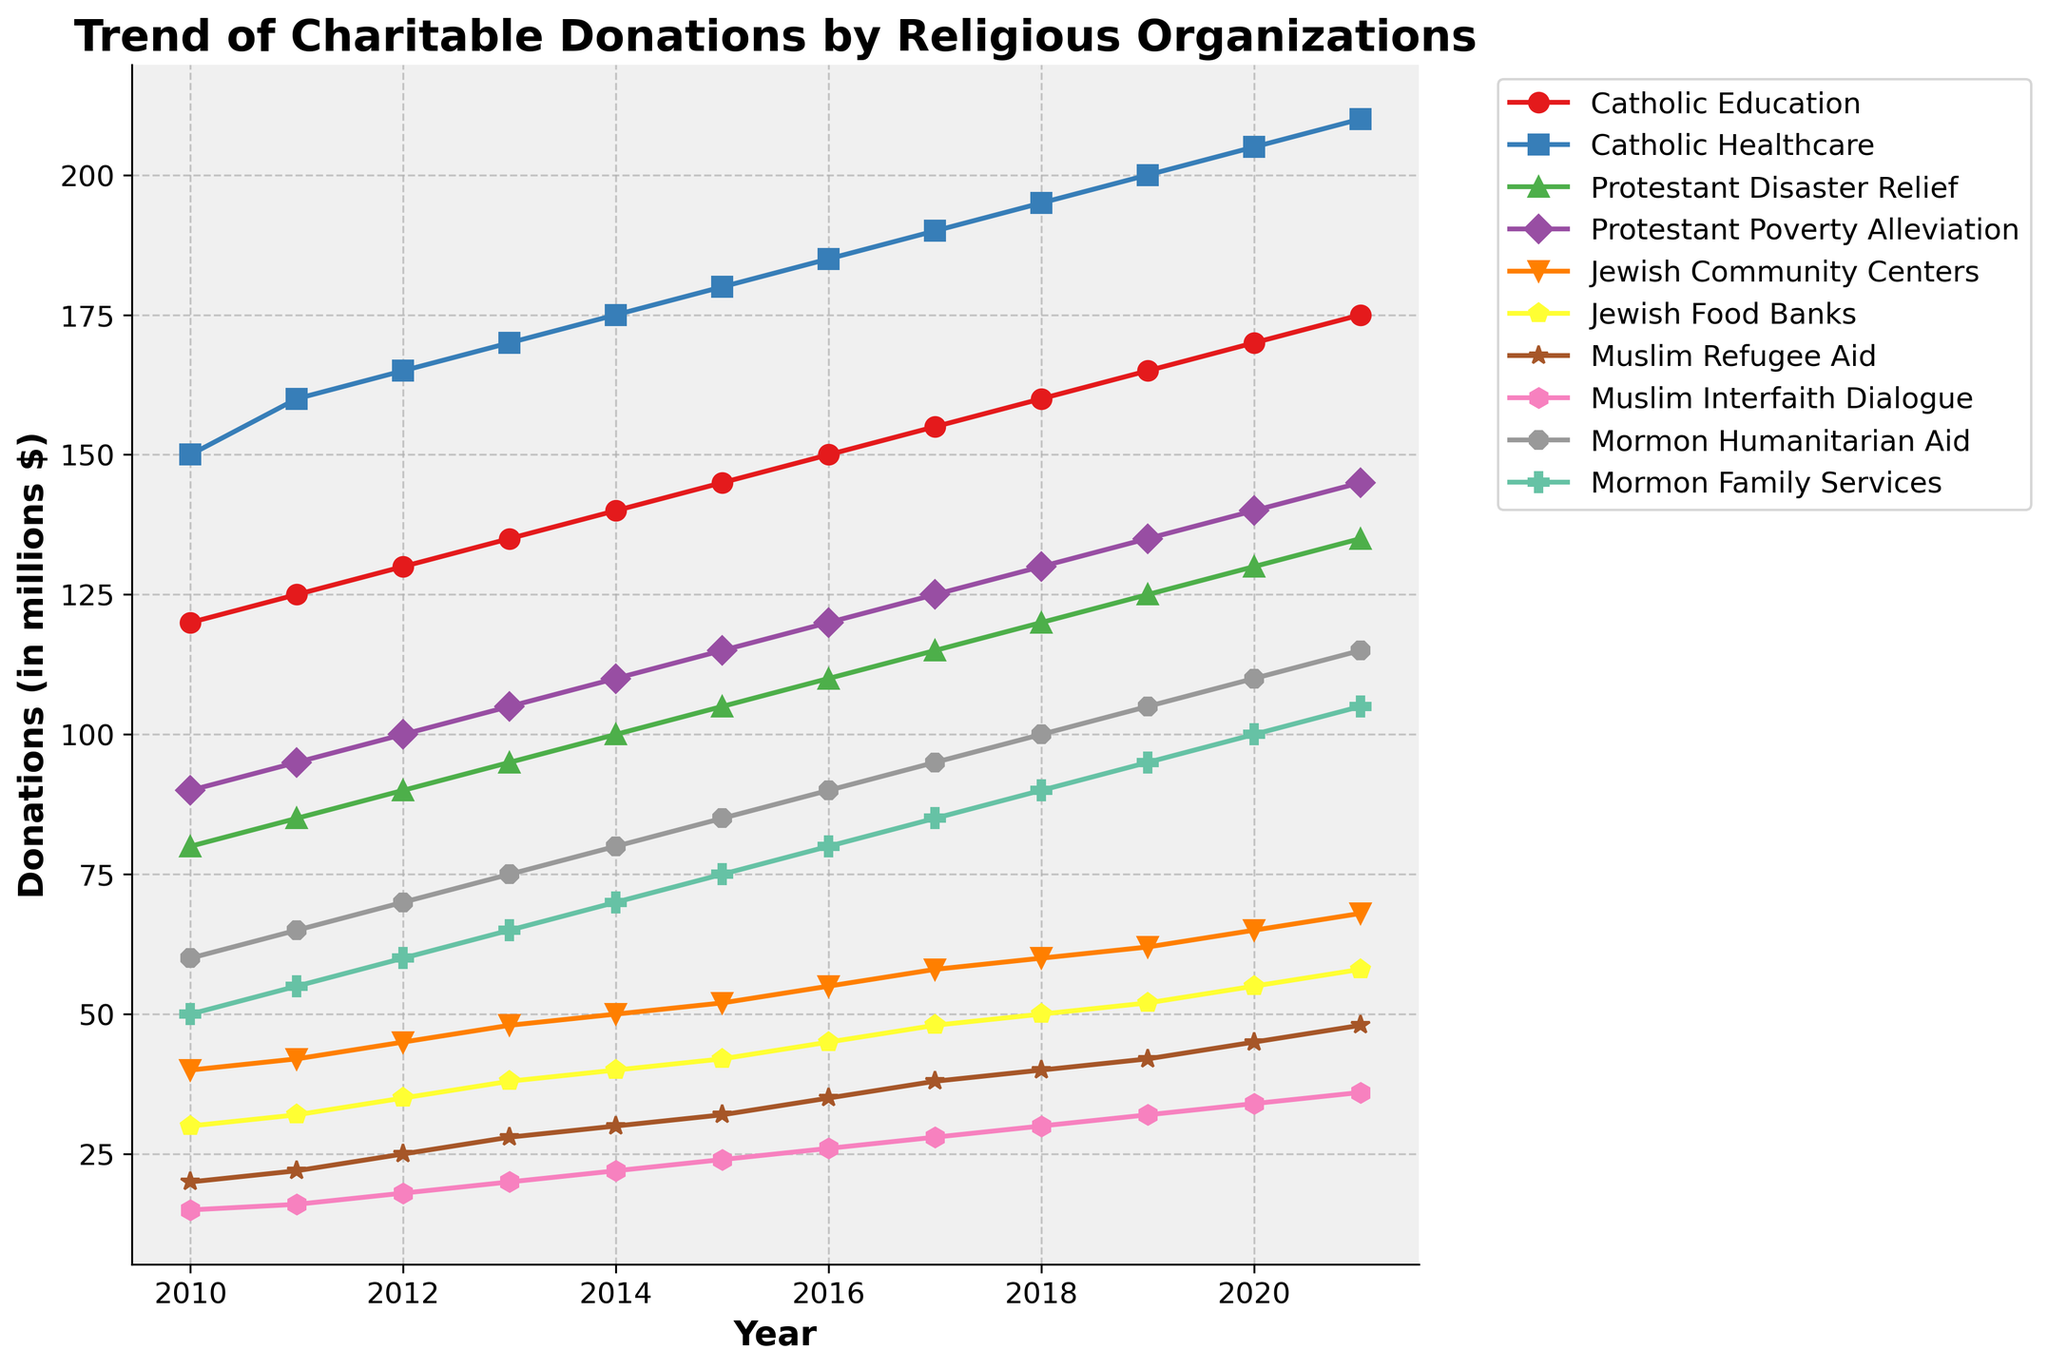What was the total amount of charitable donations by Catholic organizations in 2020? In 2020, Catholic Education received 170 million and Catholic Healthcare received 205 million. Add these values to get 170 + 205 = 375 million
Answer: 375 million Which cause saw the highest increase in donations from 2010 to 2021? Compare the donations for each cause between 2010 and 2021. The increase for each cause is Catholic Education: 175-120 = 55, Catholic Healthcare: 210-150 = 60, Protestant Disaster Relief: 135-80 = 55, Protestant Poverty Alleviation: 145-90 = 55, Jewish Community Centers: 68-40 = 28, Jewish Food Banks: 58-30 = 28, Muslim Refugee Aid: 48-20 = 28, Muslim Interfaith Dialogue: 36-15 = 21, Mormon Humanitarian Aid: 115-60 = 55, Mormon Family Services: 105-50 = 55. The highest increase is Catholic Healthcare with 60 million
Answer: Catholic Healthcare Which denomination had the highest total donations in 2011? Calculate the sum of donations for each denomination in 2011. Catholic: 125 + 160 = 285, Protestant: 185 (85+100), Jewish: 74 (42+32), Muslim: 38 (22+16), Mormon: 120 (65+55). Catholic had the highest total donations with 285 million
Answer: Catholic How did donations to Mormon Family Services change between 2015 and 2017? In 2015, Mormon Family Services received 75 million in donations. In 2017, it received 85 million. Calculate the difference: 85 - 75 = 10 million
Answer: Increased by 10 million Which year saw the highest donations to Protestant Disaster Relief? Look at the values for Protestant Disaster Relief across the years. The highest donation amount is 135 million in 2021
Answer: 2021 By how much did donations to Jewish Food Banks increase from 2014 to 2020? Donations to Jewish Food Banks were 40 million in 2014 and 55 million in 2020. Calculate the difference: 55 - 40 = 15 million
Answer: 15 million Which cause had a higher donation in 2010, Muslim Refugee Aid or Mormon Humanitarian Aid? In 2010, Muslim Refugee Aid received 20 million and Mormon Humanitarian Aid received 60 million. 60 million is greater than 20 million
Answer: Mormon Humanitarian Aid What's the average annual donation to Protestant Poverty Alleviation from 2010 to 2021? Add the annual donations from 2010 to 2021: 90 + 95 + 100 + 105 + 110 + 115 + 120 + 125+ 130+ 135+ 140 + 145 = 1400 million. Divide by the number of years (12) to get the average: 1400 / 12 = 116.67 million
Answer: 116.67 million Which religious organization has the least variability in donations over the years? Evaluate the variability by comparing the range (max value - min value) for each organization. Catholic Education: 175-120 = 55, Catholic Healthcare: 210-150 = 60, Protestant Disaster Relief: 135-80 = 55, Protestant Poverty Alleviation: 145-90=55, Jewish Community Centers: 68-40 = 28, Jewish Food Banks: 58-30 = 28, Muslim Refugee Aid: 48-20 = 28, Muslim Interfaith Dialogue: 36-15 = 21, Mormon Humanitarian Aid: 115-60 = 55, Mormon Family Services: 105-50 = 55. Muslim Interfaith Dialogue has the smallest range (21)
Answer: Muslim Interfaith Dialogue 